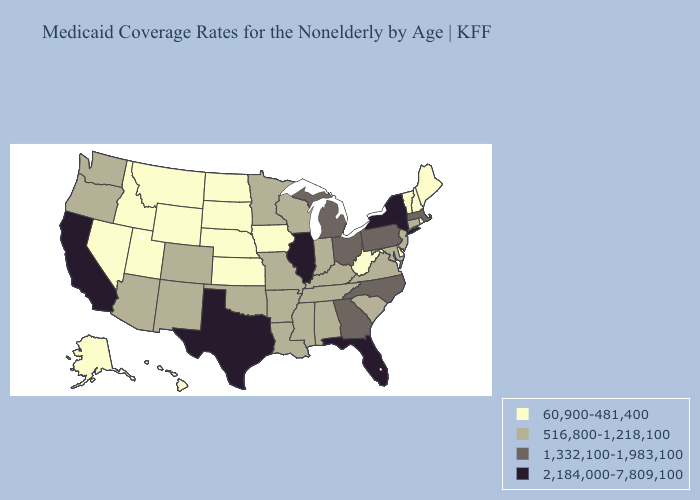What is the lowest value in the USA?
Be succinct. 60,900-481,400. Does Kansas have a lower value than New Hampshire?
Concise answer only. No. What is the highest value in the West ?
Quick response, please. 2,184,000-7,809,100. What is the highest value in states that border Illinois?
Write a very short answer. 516,800-1,218,100. Name the states that have a value in the range 516,800-1,218,100?
Concise answer only. Alabama, Arizona, Arkansas, Colorado, Connecticut, Indiana, Kentucky, Louisiana, Maryland, Minnesota, Mississippi, Missouri, New Jersey, New Mexico, Oklahoma, Oregon, South Carolina, Tennessee, Virginia, Washington, Wisconsin. What is the highest value in the South ?
Write a very short answer. 2,184,000-7,809,100. Name the states that have a value in the range 2,184,000-7,809,100?
Keep it brief. California, Florida, Illinois, New York, Texas. What is the value of Georgia?
Keep it brief. 1,332,100-1,983,100. What is the lowest value in states that border California?
Concise answer only. 60,900-481,400. What is the value of Florida?
Write a very short answer. 2,184,000-7,809,100. Among the states that border Kansas , which have the highest value?
Answer briefly. Colorado, Missouri, Oklahoma. What is the lowest value in the USA?
Concise answer only. 60,900-481,400. Name the states that have a value in the range 1,332,100-1,983,100?
Keep it brief. Georgia, Massachusetts, Michigan, North Carolina, Ohio, Pennsylvania. Which states hav the highest value in the West?
Quick response, please. California. Name the states that have a value in the range 516,800-1,218,100?
Answer briefly. Alabama, Arizona, Arkansas, Colorado, Connecticut, Indiana, Kentucky, Louisiana, Maryland, Minnesota, Mississippi, Missouri, New Jersey, New Mexico, Oklahoma, Oregon, South Carolina, Tennessee, Virginia, Washington, Wisconsin. 